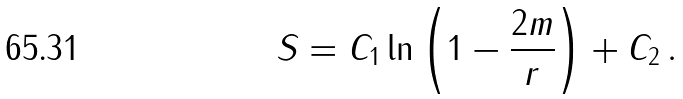<formula> <loc_0><loc_0><loc_500><loc_500>S = C _ { 1 } \ln \left ( 1 - \frac { 2 m } { r } \right ) + C _ { 2 } \, .</formula> 